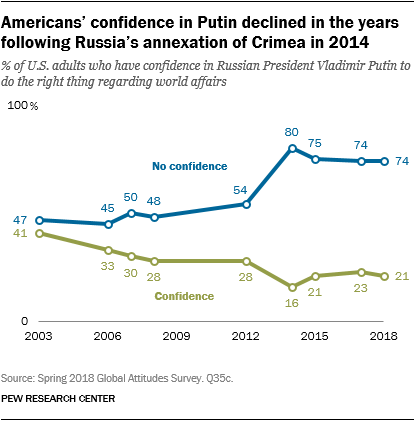Identify some key points in this picture. The leftmost value of a confidence graph is 41. The sum of the first three values of the blue graph is less than or equal to 200. 